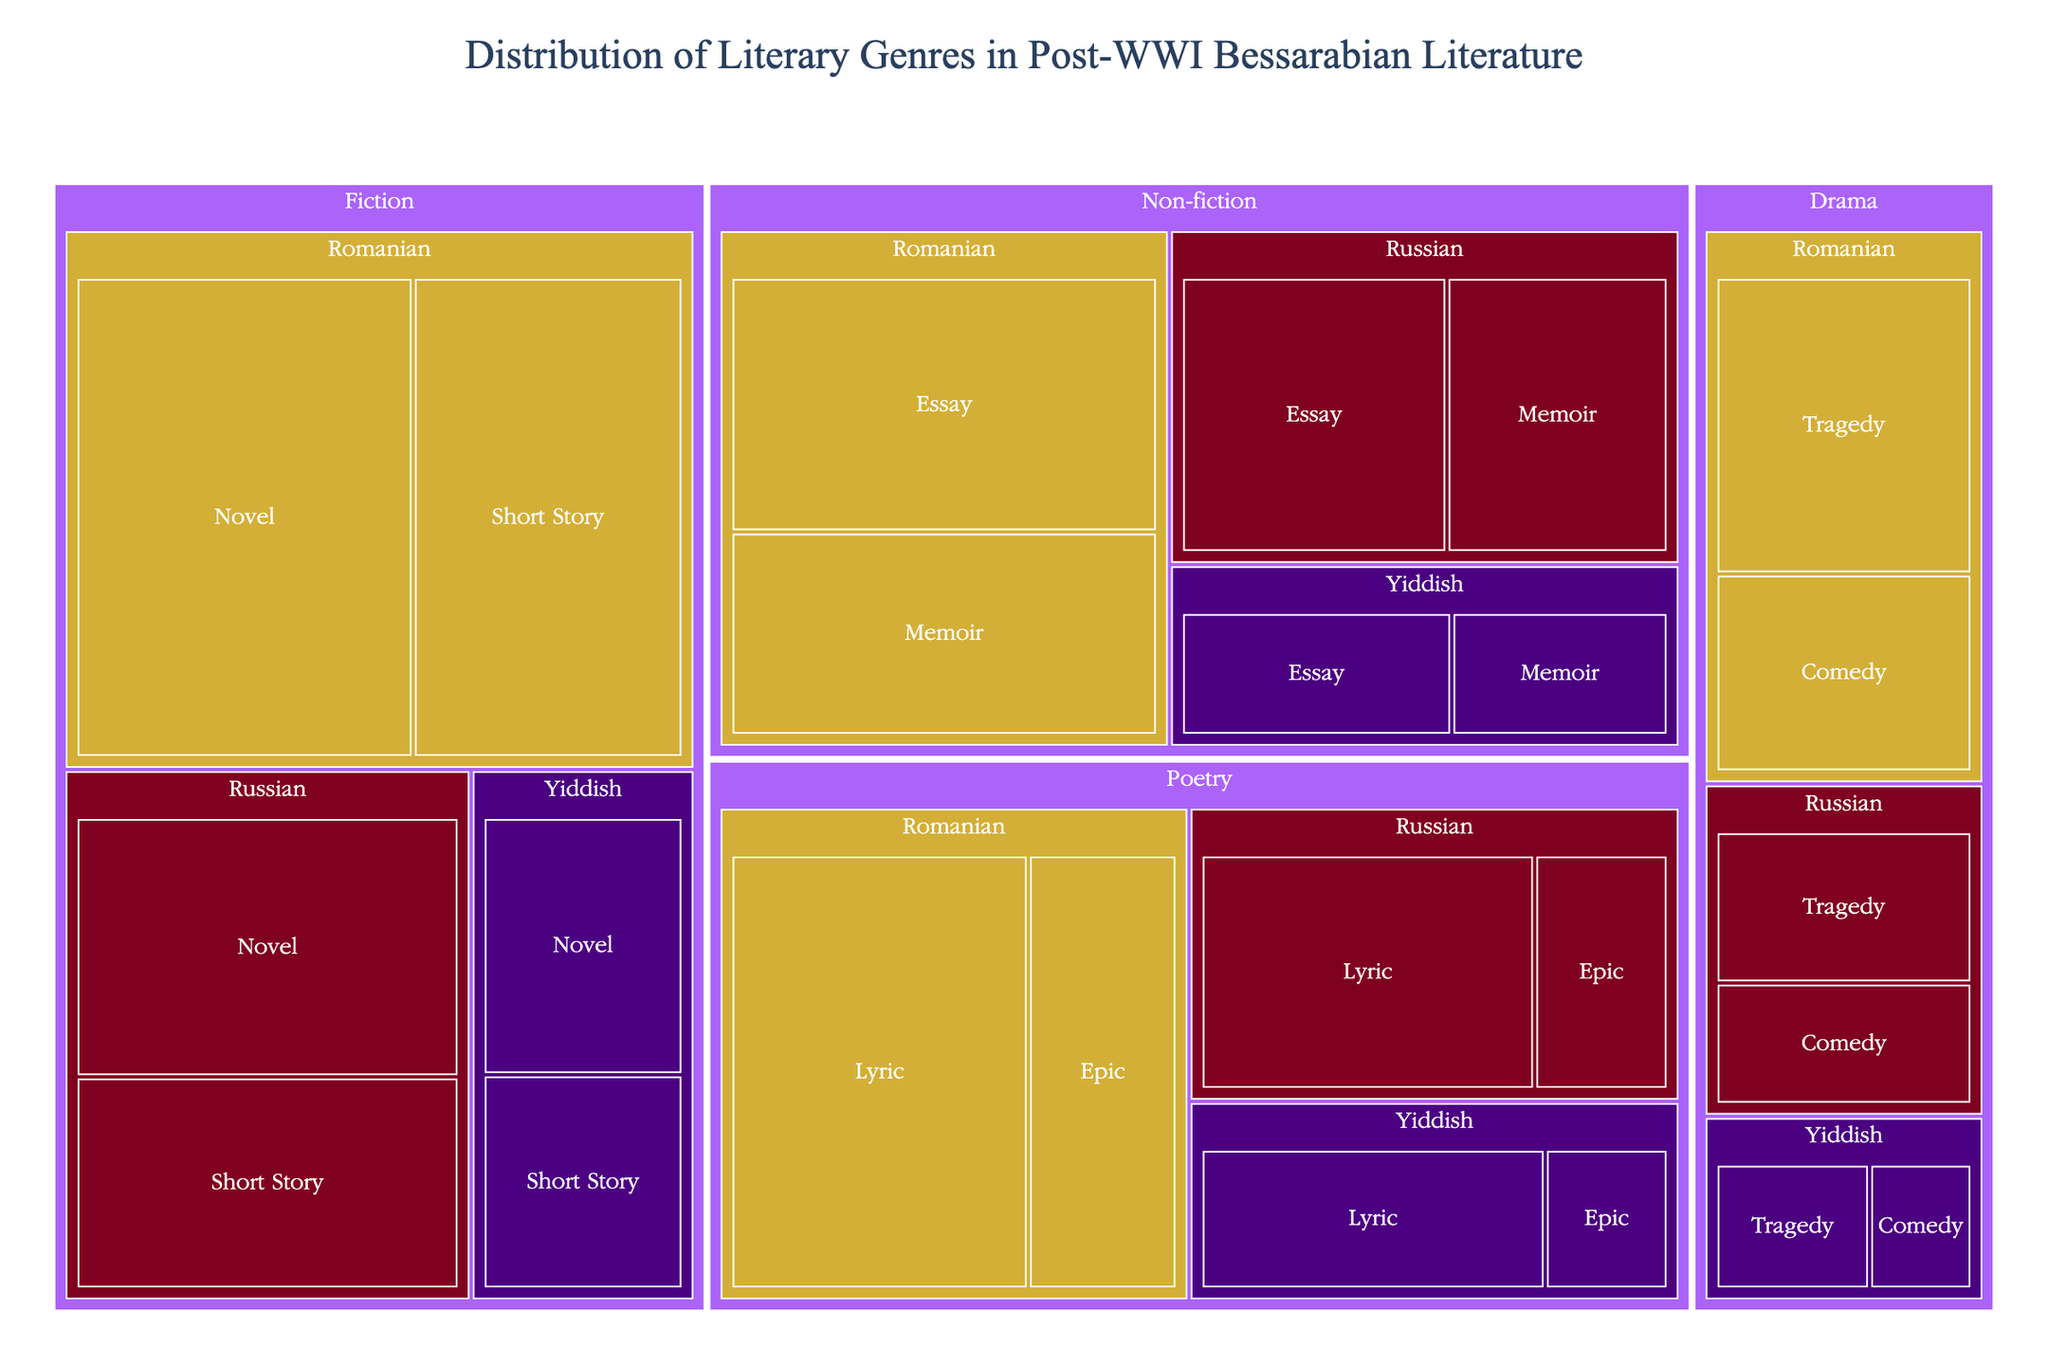What is the title of the treemap? The title of the treemap is typically displayed at the top of the figure, summarizing its content. The title for this treemap is 'Distribution of Literary Genres in Post-WWI Bessarabian Literature'.
Answer: Distribution of Literary Genres in Post-WWI Bessarabian Literature What language has the highest value in the 'Fiction' genre? To find this, look at the 'Fiction' genre and compare the values associated with each language. Romanian has 35 for Novel and 28 for Short Story, totaling 63. Russian has 22 for Novel and 18 for Short Story, totaling 40. Yiddish has 12 for Novel and 10 for Short Story, totaling 22. Romanian has the highest value.
Answer: Romanian Which sub-genre under 'Non-fiction' has a higher value, Essay or Memoir? Within the 'Non-fiction' genre, compare the values for the sub-genres Essay and Memoir. The values for Essay are 25 (Romanian), 18 (Russian), and 10 (Yiddish), while for Memoir, they are 20 (Romanian), 15 (Russian), and 8 (Yiddish). Essay consistently has higher values across all languages.
Answer: Essay Between Russian and Yiddish Drama, which language has a greater combined value for 'Comedy' and 'Tragedy'? Sum up the values for 'Comedy' and 'Tragedy' within the Drama genre for both Russian and Yiddish. Russian Drama has 10 (Tragedy) + 8 (Comedy) = 18. Yiddish Drama has 6 (Tragedy) + 4 (Comedy) = 10. Russian Drama has a greater combined value.
Answer: Russian What is the total combined value of 'Poetry' in all languages? To get the total combined value, sum up the values for all sub-genres of Poetry across all languages. Lyric: 30 (Romanian) + 20 (Russian) + 14 (Yiddish) = 64. Epic: 15 (Romanian) + 8 (Russian) + 5 (Yiddish) = 28. The total is 64 + 28 = 92.
Answer: 92 How does the value for Romanian Novels in 'Fiction' compare to Russian Novels in 'Non-fiction'? Romanian Novels in Fiction have a value of 35. Russian Essays in Non-fiction have a value of 18 and Russian Memoirs have a value of 15, totaling 33. Romanian Novels in Fiction (35) have a slightly higher value than Russian Non-fiction (33).
Answer: Romanian Novels in Fiction have a slightly higher value Which sub-genre in Romanian 'Drama' has a lower value, Comedy or Tragedy? In the Romanian Drama category, compare the values for the sub-genres Comedy and Tragedy. Comedy has 12, while Tragedy has 18. Comedy has a lower value than Tragedy.
Answer: Comedy What is the average value of all 'Yiddish' sub-genres in the 'Poetry' category? To find the average value for all Yiddish sub-genres in Poetry, sum their values and divide by the number of sub-genres. Lyric has 14 and Epic has 5, totaling 14 + 5 = 19. There are 2 sub-genres, so the average is 19 / 2 = 9.5.
Answer: 9.5 Which has a higher total value, 'Non-fiction' or 'Fiction' across all languages? Sum up the values across all languages for each genre. Non-fiction: Romanian (25+20) + Russian (18+15) + Yiddish (10+8) = 53 + 33 + 18 = 104. Fiction: Romanian (35+28) + Russian (22+18) + Yiddish (12+10) = 63 + 40 + 22 = 125. Fiction has a higher total value.
Answer: Fiction 